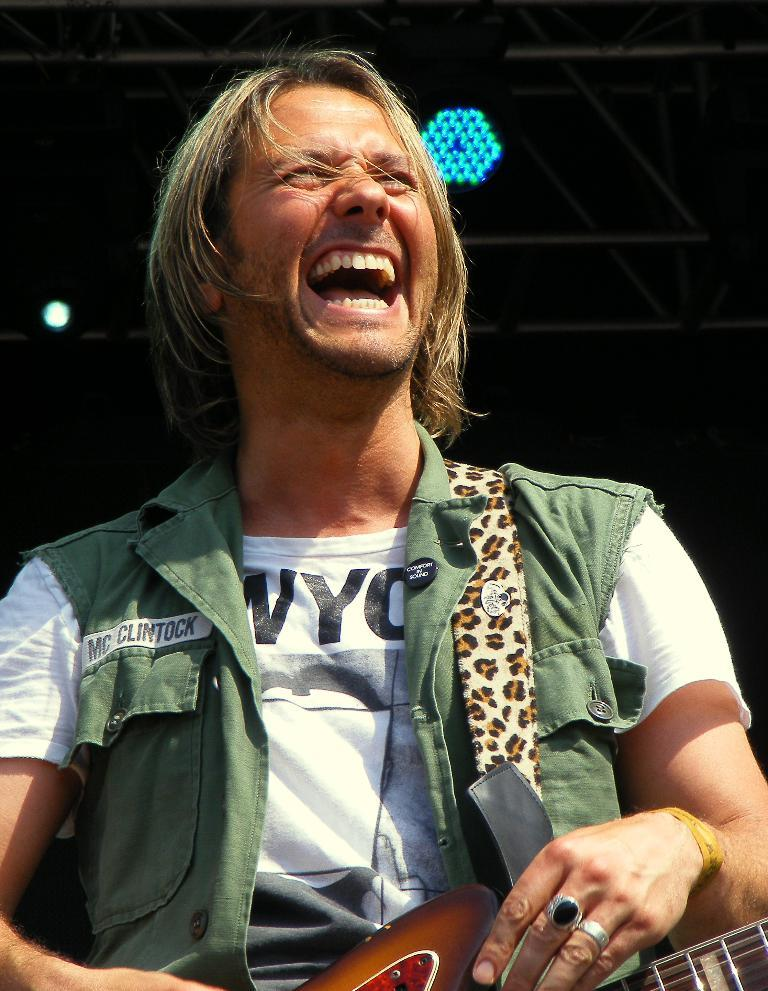What is the main subject of the image? There is a man in the image. What is the man doing in the image? The man is laughing. What object is the man holding in the image? The man is holding a guitar in his hand. What type of tax system is being discussed in the image? There is no discussion of a tax system in the image; it features a man laughing while holding a guitar. 